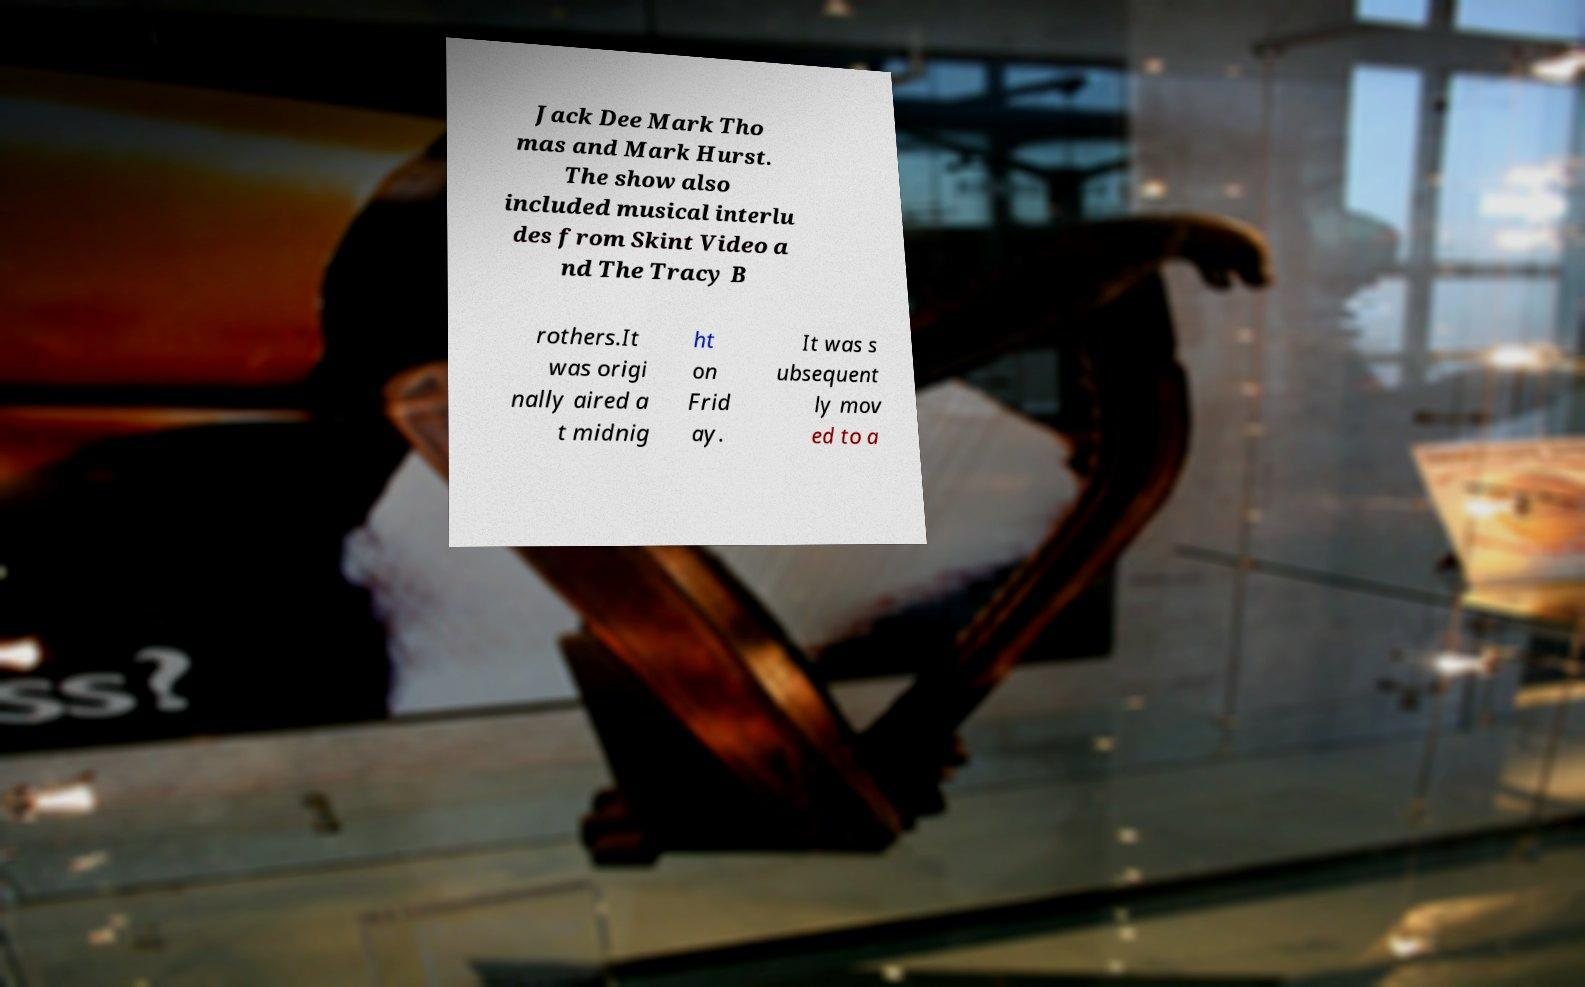Please read and relay the text visible in this image. What does it say? Jack Dee Mark Tho mas and Mark Hurst. The show also included musical interlu des from Skint Video a nd The Tracy B rothers.It was origi nally aired a t midnig ht on Frid ay. It was s ubsequent ly mov ed to a 